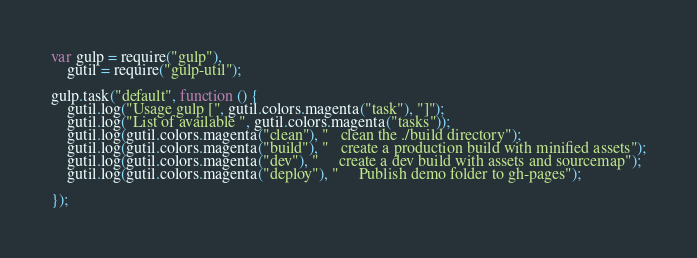Convert code to text. <code><loc_0><loc_0><loc_500><loc_500><_JavaScript_>var gulp = require("gulp"),
    gutil = require("gulp-util");

gulp.task("default", function () {
    gutil.log("Usage gulp [", gutil.colors.magenta("task"), "]");
    gutil.log("List of available ", gutil.colors.magenta("tasks"));
    gutil.log(gutil.colors.magenta("clean"), "   clean the ./build directory");
    gutil.log(gutil.colors.magenta("build"), "   create a production build with minified assets");
    gutil.log(gutil.colors.magenta("dev"), "     create a dev build with assets and sourcemap");
    gutil.log(gutil.colors.magenta("deploy"), "     Publish demo folder to gh-pages");

});
</code> 